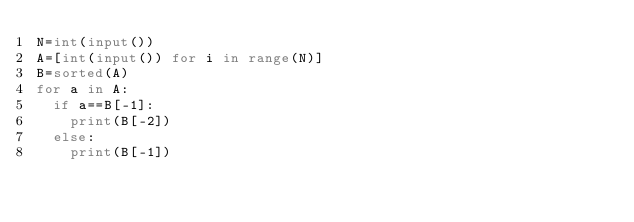<code> <loc_0><loc_0><loc_500><loc_500><_Python_>N=int(input())
A=[int(input()) for i in range(N)]
B=sorted(A)
for a in A:
  if a==B[-1]:
    print(B[-2])
  else:
    print(B[-1])</code> 